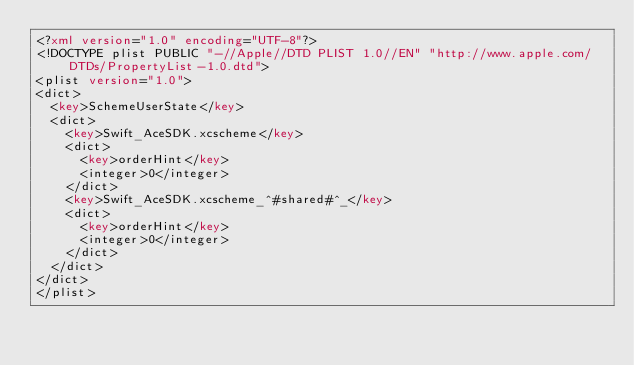Convert code to text. <code><loc_0><loc_0><loc_500><loc_500><_XML_><?xml version="1.0" encoding="UTF-8"?>
<!DOCTYPE plist PUBLIC "-//Apple//DTD PLIST 1.0//EN" "http://www.apple.com/DTDs/PropertyList-1.0.dtd">
<plist version="1.0">
<dict>
	<key>SchemeUserState</key>
	<dict>
		<key>Swift_AceSDK.xcscheme</key>
		<dict>
			<key>orderHint</key>
			<integer>0</integer>
		</dict>
		<key>Swift_AceSDK.xcscheme_^#shared#^_</key>
		<dict>
			<key>orderHint</key>
			<integer>0</integer>
		</dict>
	</dict>
</dict>
</plist>
</code> 